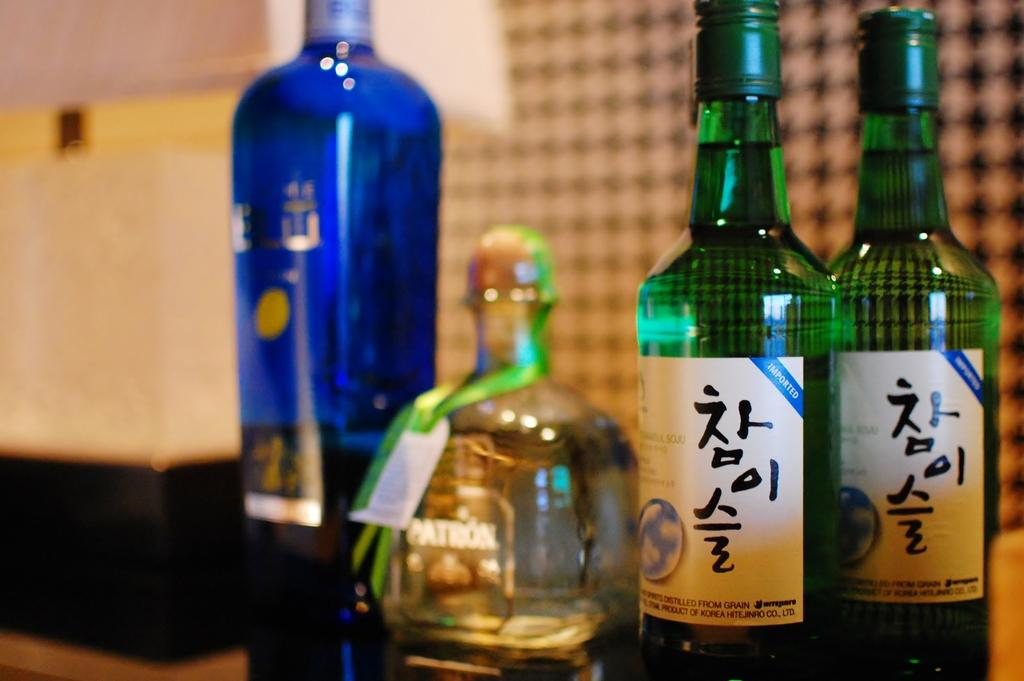<image>
Write a terse but informative summary of the picture. Several bottles of liquor lined up, one of which is Patrón. 